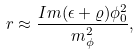Convert formula to latex. <formula><loc_0><loc_0><loc_500><loc_500>r \approx \frac { I m ( \epsilon + \varrho ) \phi _ { 0 } ^ { 2 } } { m _ { \phi } ^ { 2 } } ,</formula> 